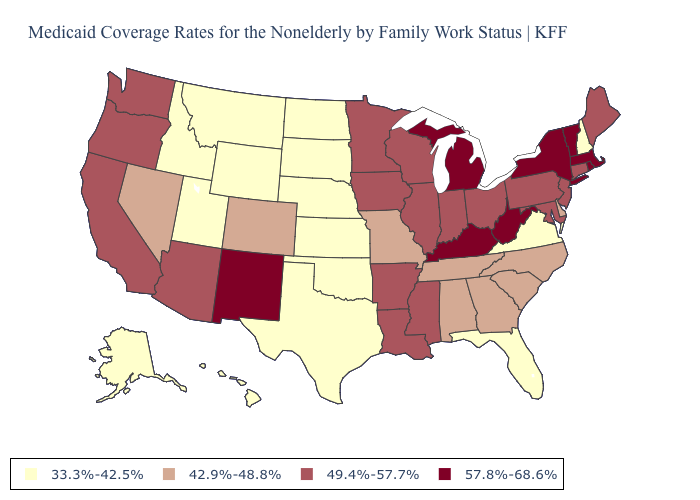Among the states that border Pennsylvania , which have the lowest value?
Concise answer only. Delaware. Does New Hampshire have the same value as Virginia?
Be succinct. Yes. Which states hav the highest value in the MidWest?
Answer briefly. Michigan. Does Hawaii have the lowest value in the West?
Keep it brief. Yes. Name the states that have a value in the range 57.8%-68.6%?
Quick response, please. Kentucky, Massachusetts, Michigan, New Mexico, New York, Rhode Island, Vermont, West Virginia. Name the states that have a value in the range 42.9%-48.8%?
Be succinct. Alabama, Colorado, Delaware, Georgia, Missouri, Nevada, North Carolina, South Carolina, Tennessee. Does the map have missing data?
Answer briefly. No. Which states have the lowest value in the USA?
Be succinct. Alaska, Florida, Hawaii, Idaho, Kansas, Montana, Nebraska, New Hampshire, North Dakota, Oklahoma, South Dakota, Texas, Utah, Virginia, Wyoming. What is the value of Montana?
Short answer required. 33.3%-42.5%. Among the states that border South Dakota , which have the lowest value?
Short answer required. Montana, Nebraska, North Dakota, Wyoming. Does Texas have the lowest value in the USA?
Be succinct. Yes. What is the highest value in states that border Oregon?
Give a very brief answer. 49.4%-57.7%. What is the value of Idaho?
Write a very short answer. 33.3%-42.5%. Name the states that have a value in the range 57.8%-68.6%?
Give a very brief answer. Kentucky, Massachusetts, Michigan, New Mexico, New York, Rhode Island, Vermont, West Virginia. 